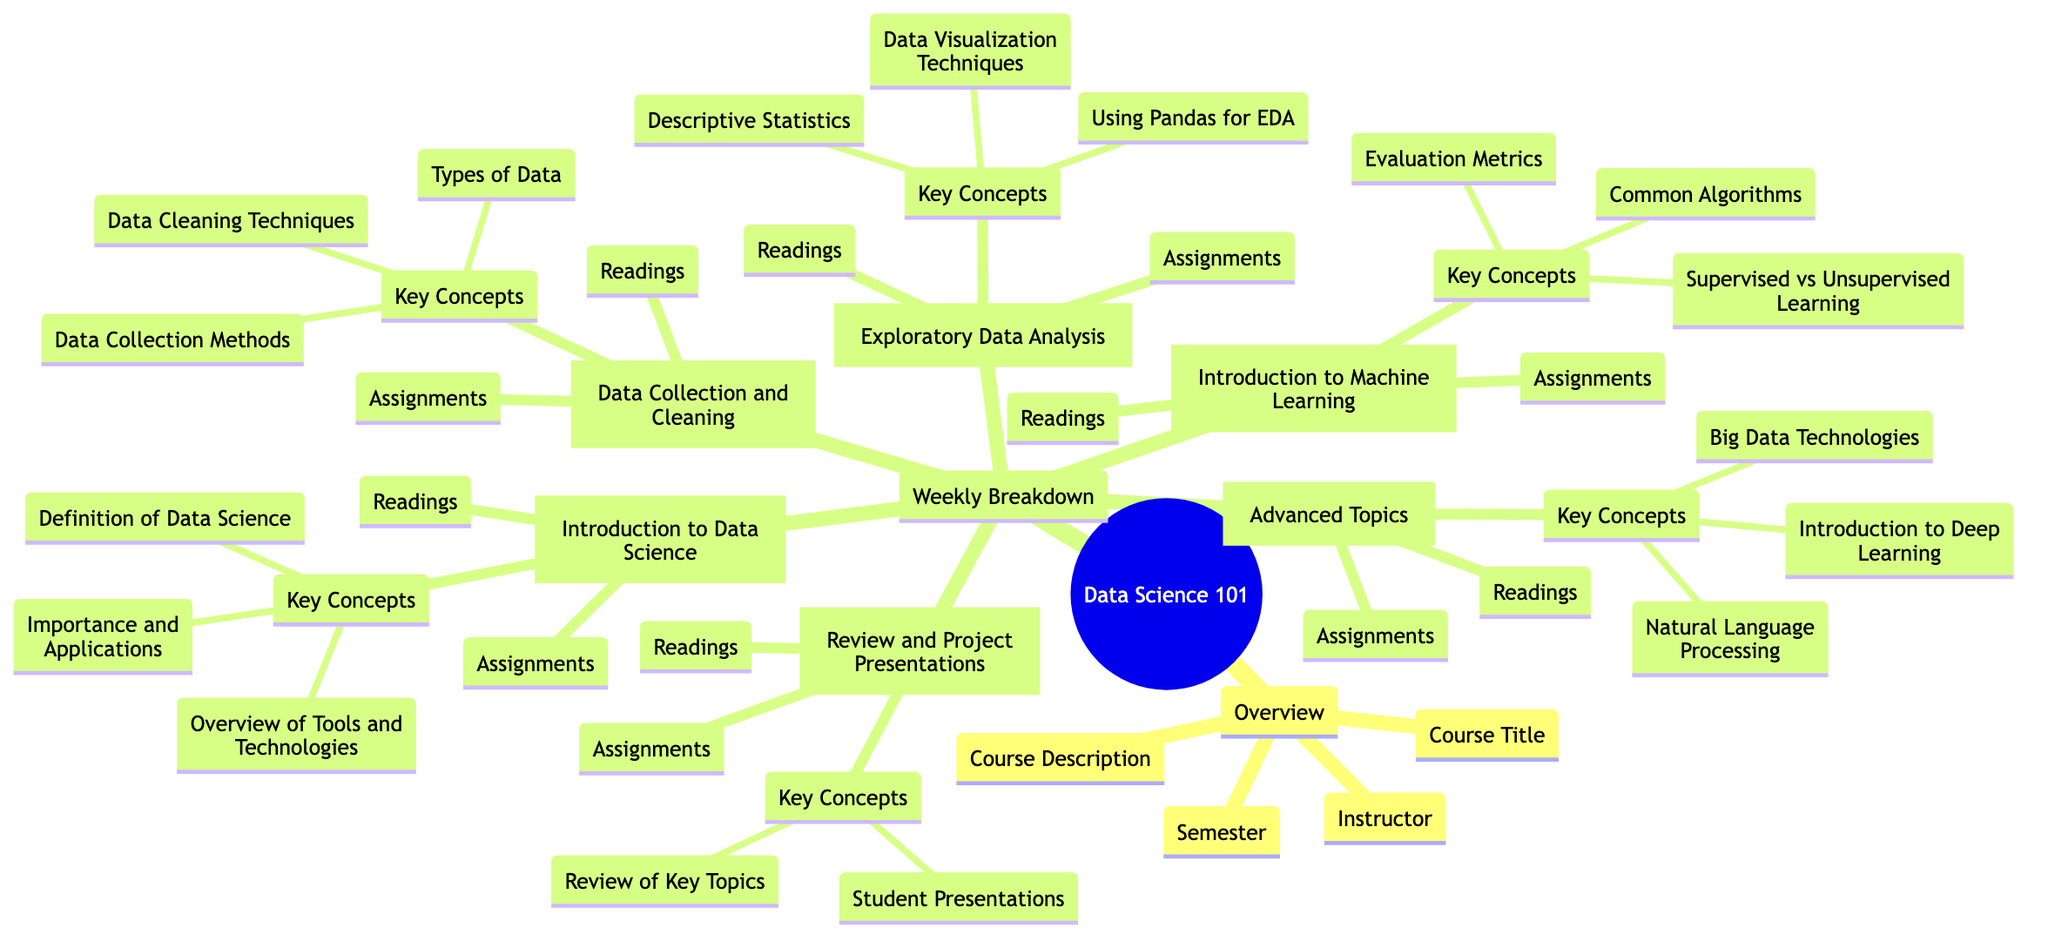What is the course title in the overview? The course title is explicitly stated in the "Overview" section of the diagram. It is the first piece of information presented under that section.
Answer: Data Science 101 Who is the instructor for this course? The instructor's name is listed directly under the "Overview" section as well. It is the second item displayed.
Answer: Professor John Doe How many weeks are detailed in the weekly breakdown? The "Weekly Breakdown" section contains individual nodes for each week listed, and counting these nodes gives the total number of weeks. The weeks included are Week 1, Week 2, Week 3, Week 4, Week 5, and a Review Week.
Answer: 6 What key concept is introduced in Week 2? The key concepts for each week are listed directly under each week's topic. For Week 2, the key concept is the first item mentioned under that node.
Answer: Data Collection Methods Which week covers Exploratory Data Analysis? The week dedicated to Exploratory Data Analysis is specifically labeled in its respective node under the "Weekly Breakdown" section and is easily identifiable by the week number.
Answer: Week 3 What is the topic of Week 5? Each week has a clearly defined topic that is presented prominently. In Week 5, the topic is explicitly stated in the label of that week.
Answer: Advanced Topics What assignment is due in Week 4? Assignments for each week are clearly listed under their respective weeks. By looking at Week 4's assignments, one can identify an example assignment due for that week.
Answer: Implement a Simple Linear Regression Model What is the reading for Week 3? Each week also has its specific readings listed, making it easy to find the assigned reading for Week 3. The reading is the only entry in the "Readings" node for that week.
Answer: Chapter 4 of 'Python Data Science Handbook' by VanderPlas What are the key concepts for the Review Week? For the Review Week, the key concepts are listed and reflect the overall goal of that week, which involves revisiting critical topics for final preparation. The concepts are stated plainly as the first item under that week.
Answer: Review of Key Topics 